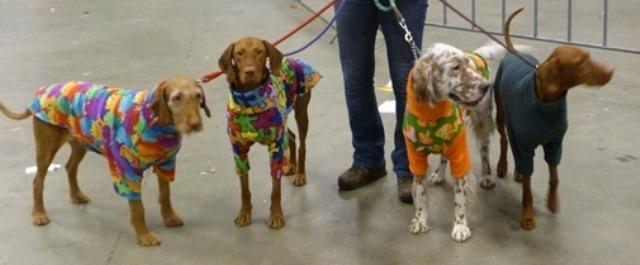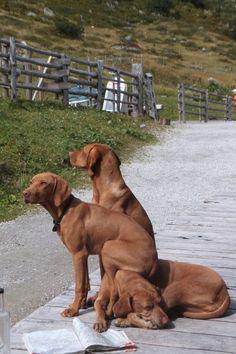The first image is the image on the left, the second image is the image on the right. For the images shown, is this caption "The dog in one of the images is standing in the grass." true? Answer yes or no. No. The first image is the image on the left, the second image is the image on the right. For the images displayed, is the sentence "Each image contains one red-orange adult dog, and one image shows a dog in a black collar standing on all fours in the grass facing rightward." factually correct? Answer yes or no. No. 